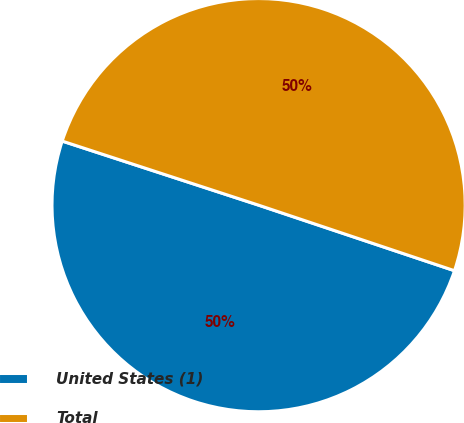Convert chart to OTSL. <chart><loc_0><loc_0><loc_500><loc_500><pie_chart><fcel>United States (1)<fcel>Total<nl><fcel>49.88%<fcel>50.12%<nl></chart> 